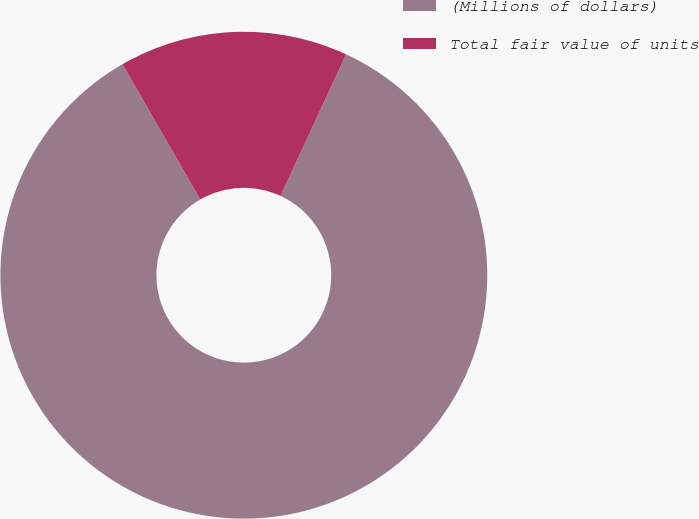<chart> <loc_0><loc_0><loc_500><loc_500><pie_chart><fcel>(Millions of dollars)<fcel>Total fair value of units<nl><fcel>84.79%<fcel>15.21%<nl></chart> 